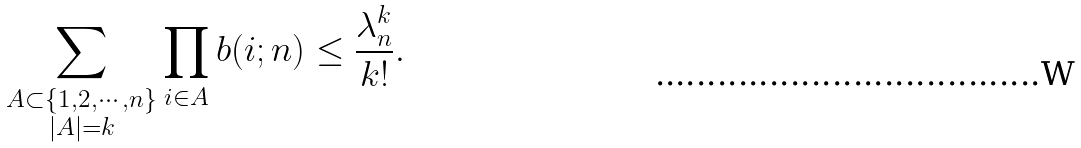Convert formula to latex. <formula><loc_0><loc_0><loc_500><loc_500>\sum _ { \substack { A \subset \{ 1 , 2 , \cdots , n \} \\ | A | = k } } \prod _ { i \in A } b ( i ; n ) \leq \frac { \lambda _ { n } ^ { k } } { k ! } .</formula> 